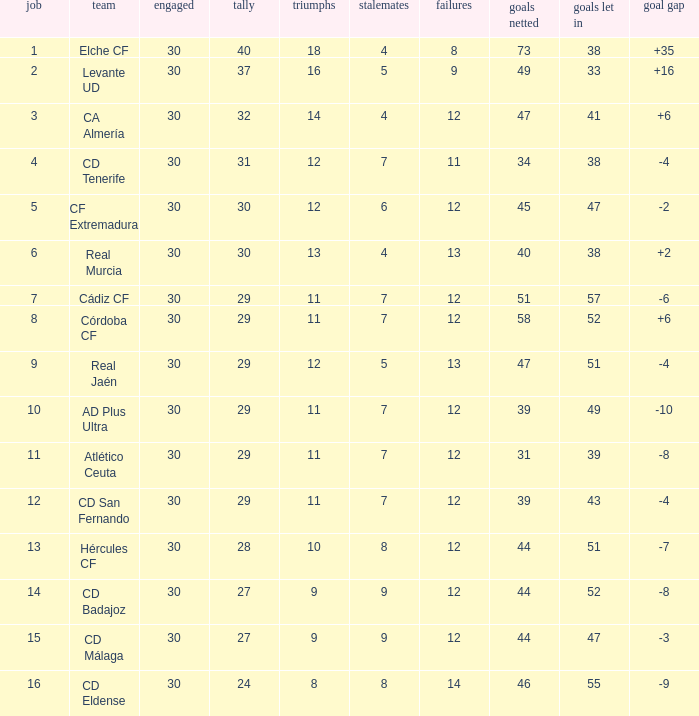What is the total number of losses with less than 73 goals for, less than 11 wins, more than 24 points, and a position greater than 15? 0.0. 